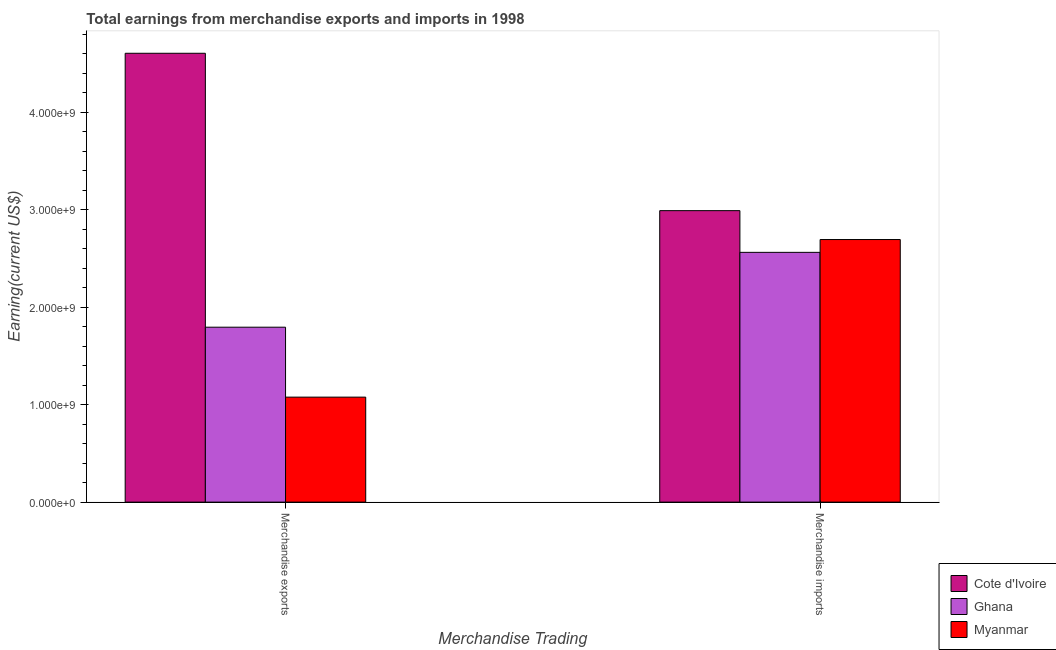How many groups of bars are there?
Make the answer very short. 2. Are the number of bars per tick equal to the number of legend labels?
Give a very brief answer. Yes. How many bars are there on the 2nd tick from the left?
Keep it short and to the point. 3. What is the label of the 2nd group of bars from the left?
Make the answer very short. Merchandise imports. What is the earnings from merchandise exports in Myanmar?
Your answer should be very brief. 1.08e+09. Across all countries, what is the maximum earnings from merchandise imports?
Offer a terse response. 2.99e+09. Across all countries, what is the minimum earnings from merchandise imports?
Keep it short and to the point. 2.56e+09. In which country was the earnings from merchandise imports maximum?
Offer a terse response. Cote d'Ivoire. In which country was the earnings from merchandise exports minimum?
Ensure brevity in your answer.  Myanmar. What is the total earnings from merchandise imports in the graph?
Keep it short and to the point. 8.25e+09. What is the difference between the earnings from merchandise exports in Cote d'Ivoire and that in Ghana?
Make the answer very short. 2.81e+09. What is the difference between the earnings from merchandise exports in Ghana and the earnings from merchandise imports in Myanmar?
Your answer should be compact. -9.00e+08. What is the average earnings from merchandise imports per country?
Offer a very short reply. 2.75e+09. What is the difference between the earnings from merchandise exports and earnings from merchandise imports in Myanmar?
Offer a terse response. -1.62e+09. What is the ratio of the earnings from merchandise exports in Myanmar to that in Ghana?
Your response must be concise. 0.6. Is the earnings from merchandise exports in Cote d'Ivoire less than that in Myanmar?
Offer a terse response. No. What does the 3rd bar from the left in Merchandise imports represents?
Your answer should be very brief. Myanmar. What does the 3rd bar from the right in Merchandise exports represents?
Give a very brief answer. Cote d'Ivoire. Are all the bars in the graph horizontal?
Offer a very short reply. No. How many countries are there in the graph?
Provide a short and direct response. 3. Does the graph contain any zero values?
Your answer should be very brief. No. What is the title of the graph?
Offer a terse response. Total earnings from merchandise exports and imports in 1998. What is the label or title of the X-axis?
Give a very brief answer. Merchandise Trading. What is the label or title of the Y-axis?
Offer a terse response. Earning(current US$). What is the Earning(current US$) in Cote d'Ivoire in Merchandise exports?
Your answer should be compact. 4.61e+09. What is the Earning(current US$) of Ghana in Merchandise exports?
Offer a very short reply. 1.80e+09. What is the Earning(current US$) in Myanmar in Merchandise exports?
Offer a terse response. 1.08e+09. What is the Earning(current US$) in Cote d'Ivoire in Merchandise imports?
Make the answer very short. 2.99e+09. What is the Earning(current US$) of Ghana in Merchandise imports?
Keep it short and to the point. 2.56e+09. What is the Earning(current US$) in Myanmar in Merchandise imports?
Give a very brief answer. 2.69e+09. Across all Merchandise Trading, what is the maximum Earning(current US$) of Cote d'Ivoire?
Provide a short and direct response. 4.61e+09. Across all Merchandise Trading, what is the maximum Earning(current US$) in Ghana?
Give a very brief answer. 2.56e+09. Across all Merchandise Trading, what is the maximum Earning(current US$) in Myanmar?
Give a very brief answer. 2.69e+09. Across all Merchandise Trading, what is the minimum Earning(current US$) of Cote d'Ivoire?
Your response must be concise. 2.99e+09. Across all Merchandise Trading, what is the minimum Earning(current US$) in Ghana?
Give a very brief answer. 1.80e+09. Across all Merchandise Trading, what is the minimum Earning(current US$) in Myanmar?
Your response must be concise. 1.08e+09. What is the total Earning(current US$) of Cote d'Ivoire in the graph?
Give a very brief answer. 7.60e+09. What is the total Earning(current US$) in Ghana in the graph?
Ensure brevity in your answer.  4.36e+09. What is the total Earning(current US$) in Myanmar in the graph?
Ensure brevity in your answer.  3.77e+09. What is the difference between the Earning(current US$) of Cote d'Ivoire in Merchandise exports and that in Merchandise imports?
Provide a succinct answer. 1.62e+09. What is the difference between the Earning(current US$) in Ghana in Merchandise exports and that in Merchandise imports?
Give a very brief answer. -7.68e+08. What is the difference between the Earning(current US$) of Myanmar in Merchandise exports and that in Merchandise imports?
Offer a very short reply. -1.62e+09. What is the difference between the Earning(current US$) of Cote d'Ivoire in Merchandise exports and the Earning(current US$) of Ghana in Merchandise imports?
Keep it short and to the point. 2.04e+09. What is the difference between the Earning(current US$) of Cote d'Ivoire in Merchandise exports and the Earning(current US$) of Myanmar in Merchandise imports?
Your response must be concise. 1.91e+09. What is the difference between the Earning(current US$) of Ghana in Merchandise exports and the Earning(current US$) of Myanmar in Merchandise imports?
Offer a very short reply. -9.00e+08. What is the average Earning(current US$) in Cote d'Ivoire per Merchandise Trading?
Offer a terse response. 3.80e+09. What is the average Earning(current US$) of Ghana per Merchandise Trading?
Ensure brevity in your answer.  2.18e+09. What is the average Earning(current US$) in Myanmar per Merchandise Trading?
Your response must be concise. 1.89e+09. What is the difference between the Earning(current US$) of Cote d'Ivoire and Earning(current US$) of Ghana in Merchandise exports?
Provide a succinct answer. 2.81e+09. What is the difference between the Earning(current US$) in Cote d'Ivoire and Earning(current US$) in Myanmar in Merchandise exports?
Your answer should be very brief. 3.53e+09. What is the difference between the Earning(current US$) of Ghana and Earning(current US$) of Myanmar in Merchandise exports?
Your response must be concise. 7.18e+08. What is the difference between the Earning(current US$) of Cote d'Ivoire and Earning(current US$) of Ghana in Merchandise imports?
Provide a succinct answer. 4.28e+08. What is the difference between the Earning(current US$) of Cote d'Ivoire and Earning(current US$) of Myanmar in Merchandise imports?
Your answer should be very brief. 2.96e+08. What is the difference between the Earning(current US$) of Ghana and Earning(current US$) of Myanmar in Merchandise imports?
Provide a short and direct response. -1.32e+08. What is the ratio of the Earning(current US$) in Cote d'Ivoire in Merchandise exports to that in Merchandise imports?
Provide a short and direct response. 1.54. What is the ratio of the Earning(current US$) in Ghana in Merchandise exports to that in Merchandise imports?
Your answer should be very brief. 0.7. What is the ratio of the Earning(current US$) in Myanmar in Merchandise exports to that in Merchandise imports?
Keep it short and to the point. 0.4. What is the difference between the highest and the second highest Earning(current US$) of Cote d'Ivoire?
Your response must be concise. 1.62e+09. What is the difference between the highest and the second highest Earning(current US$) in Ghana?
Provide a succinct answer. 7.68e+08. What is the difference between the highest and the second highest Earning(current US$) of Myanmar?
Make the answer very short. 1.62e+09. What is the difference between the highest and the lowest Earning(current US$) of Cote d'Ivoire?
Provide a succinct answer. 1.62e+09. What is the difference between the highest and the lowest Earning(current US$) of Ghana?
Provide a succinct answer. 7.68e+08. What is the difference between the highest and the lowest Earning(current US$) of Myanmar?
Ensure brevity in your answer.  1.62e+09. 